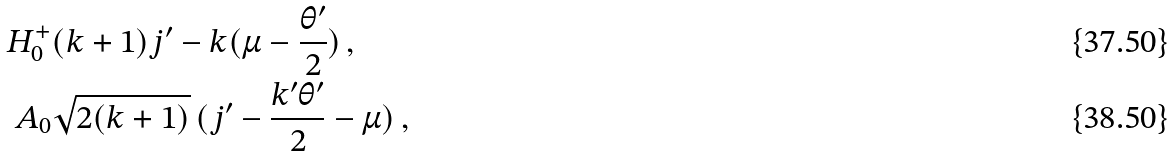Convert formula to latex. <formula><loc_0><loc_0><loc_500><loc_500>H ^ { + } _ { 0 } & ( k + 1 ) j ^ { \prime } - k ( \mu - \frac { \theta ^ { \prime } } { 2 } ) \, , \\ A _ { 0 } & \sqrt { 2 ( k + 1 ) } \, ( j ^ { \prime } - \frac { k ^ { \prime } \theta ^ { \prime } } { 2 } - \mu ) \, ,</formula> 